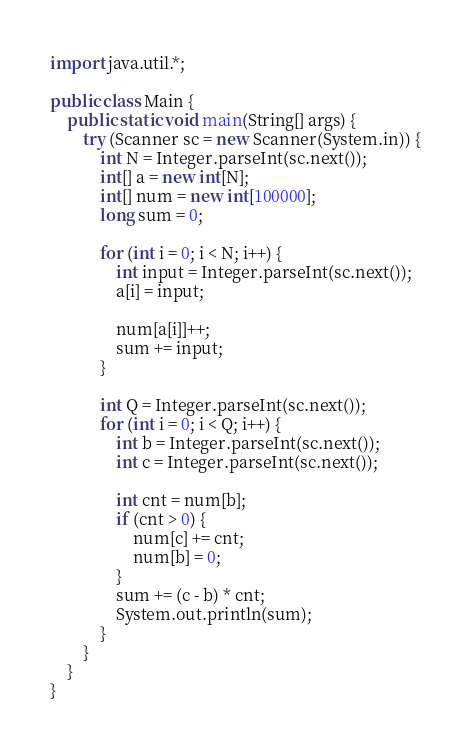Convert code to text. <code><loc_0><loc_0><loc_500><loc_500><_Java_>import java.util.*;

public class Main {
    public static void main(String[] args) {
        try (Scanner sc = new Scanner(System.in)) {
            int N = Integer.parseInt(sc.next());
            int[] a = new int[N];
            int[] num = new int[100000];
            long sum = 0;

            for (int i = 0; i < N; i++) {
                int input = Integer.parseInt(sc.next());
                a[i] = input;

                num[a[i]]++;
                sum += input;
            }

            int Q = Integer.parseInt(sc.next());
            for (int i = 0; i < Q; i++) {
                int b = Integer.parseInt(sc.next());
                int c = Integer.parseInt(sc.next());

                int cnt = num[b];
                if (cnt > 0) {
                    num[c] += cnt;
                    num[b] = 0;
                }
                sum += (c - b) * cnt;
                System.out.println(sum);
            }
        }
    }
}</code> 